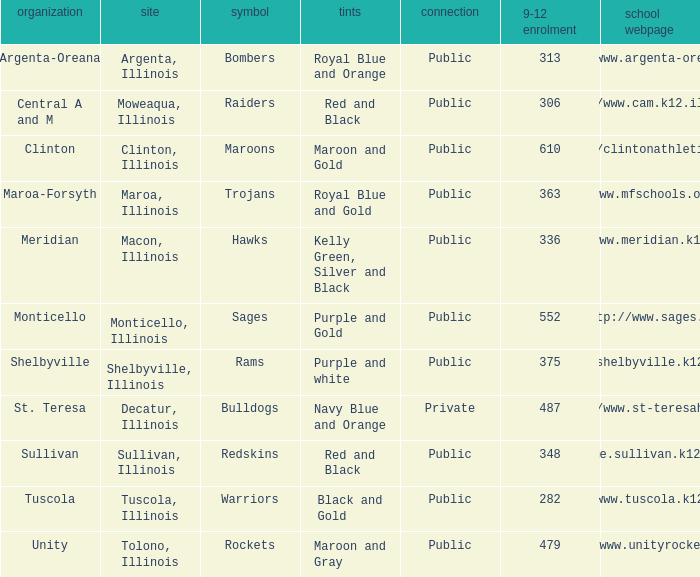How many different combinations of team colors are there in all the schools in Maroa, Illinois? 1.0. 